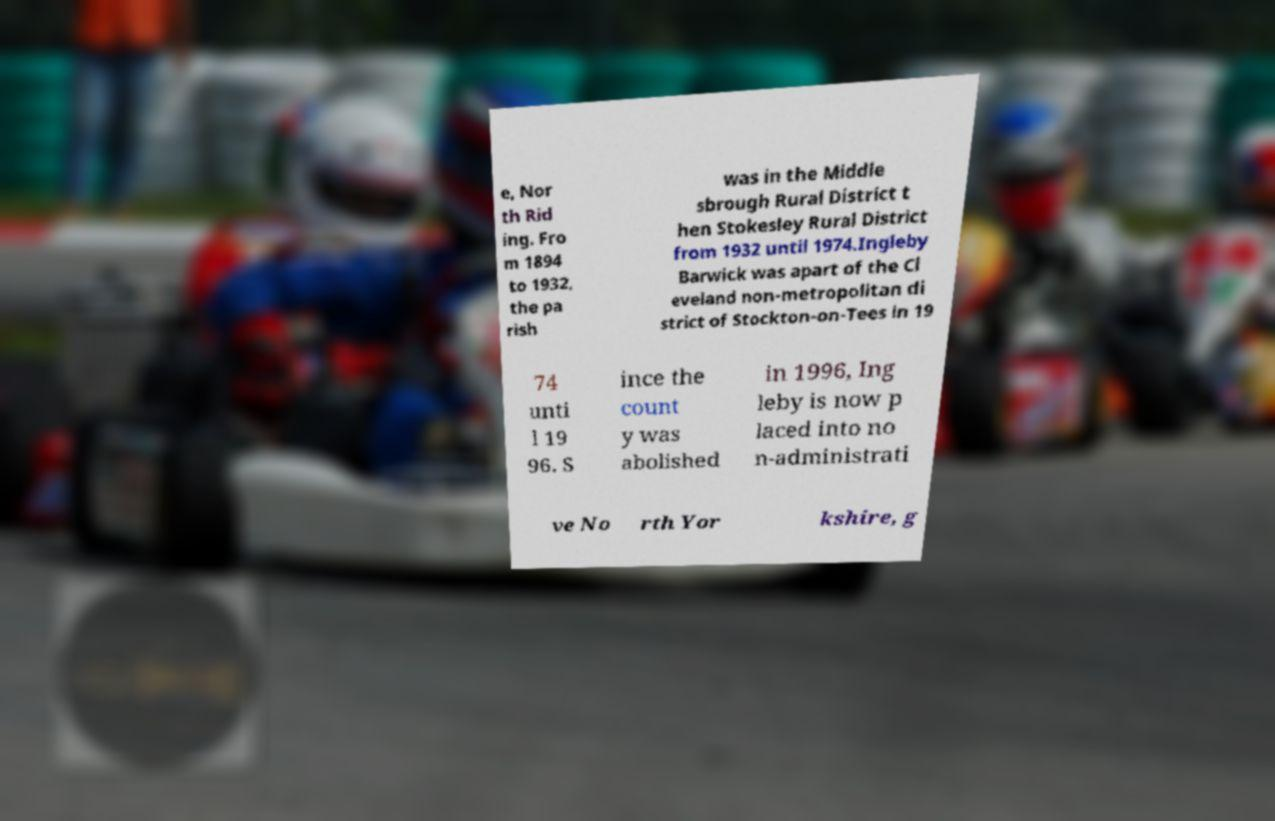Could you assist in decoding the text presented in this image and type it out clearly? e, Nor th Rid ing. Fro m 1894 to 1932, the pa rish was in the Middle sbrough Rural District t hen Stokesley Rural District from 1932 until 1974.Ingleby Barwick was apart of the Cl eveland non-metropolitan di strict of Stockton-on-Tees in 19 74 unti l 19 96. S ince the count y was abolished in 1996, Ing leby is now p laced into no n-administrati ve No rth Yor kshire, g 